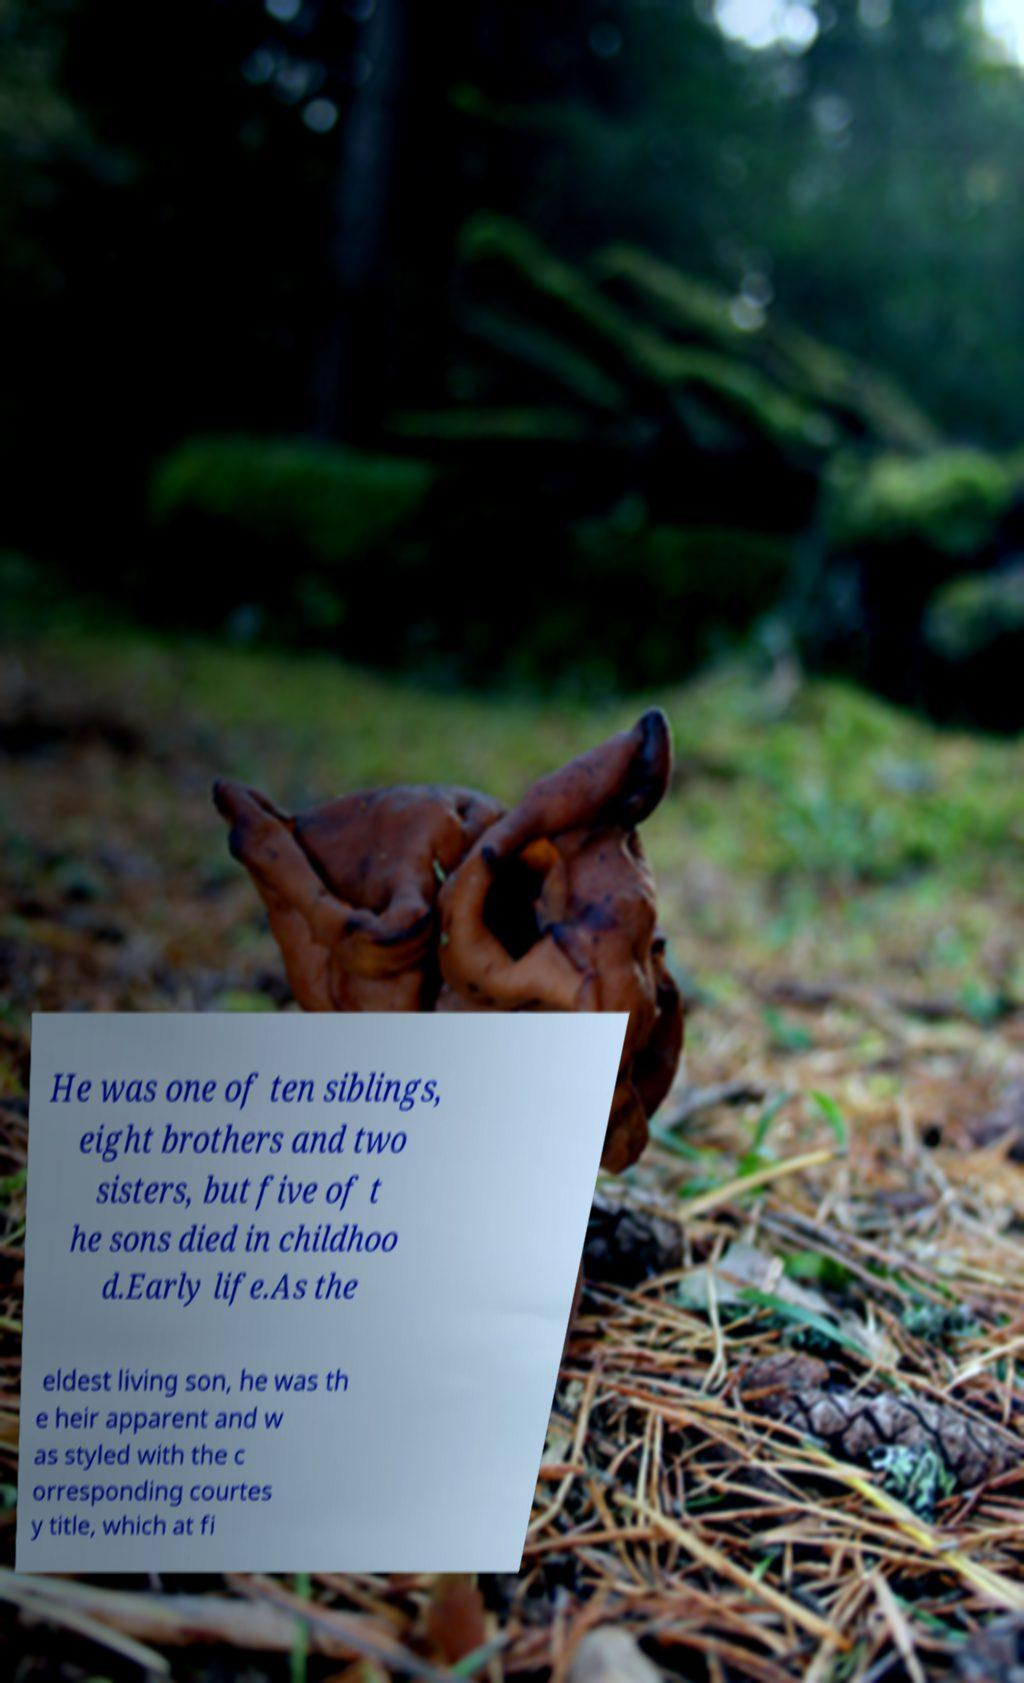Please read and relay the text visible in this image. What does it say? He was one of ten siblings, eight brothers and two sisters, but five of t he sons died in childhoo d.Early life.As the eldest living son, he was th e heir apparent and w as styled with the c orresponding courtes y title, which at fi 